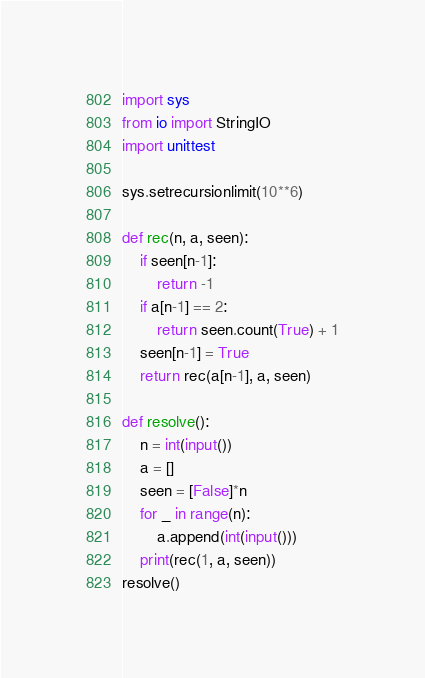Convert code to text. <code><loc_0><loc_0><loc_500><loc_500><_Python_>import sys
from io import StringIO
import unittest

sys.setrecursionlimit(10**6)

def rec(n, a, seen):
	if seen[n-1]:
		return -1
	if a[n-1] == 2:
		return seen.count(True) + 1
	seen[n-1] = True
	return rec(a[n-1], a, seen)

def resolve():
	n = int(input())
	a = []
	seen = [False]*n
	for _ in range(n):
		a.append(int(input()))
	print(rec(1, a, seen))
resolve()</code> 